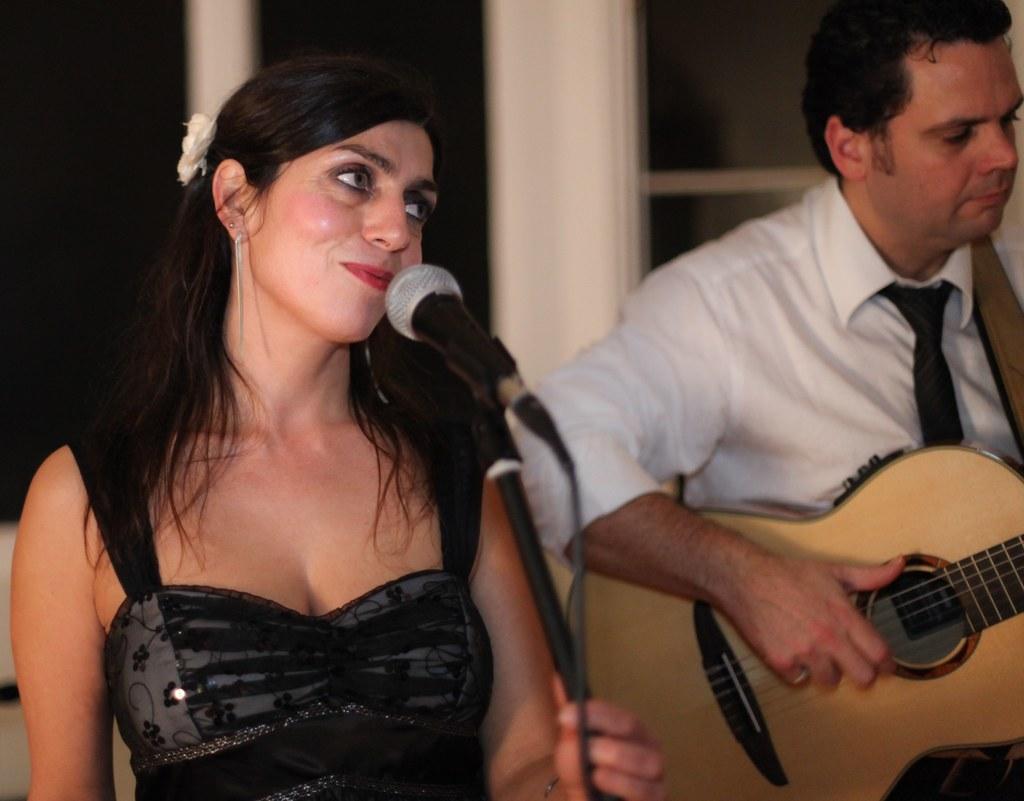Can you describe this image briefly? This picture shows a woman speaking with the help of a microphone and we see a man playing guitar 